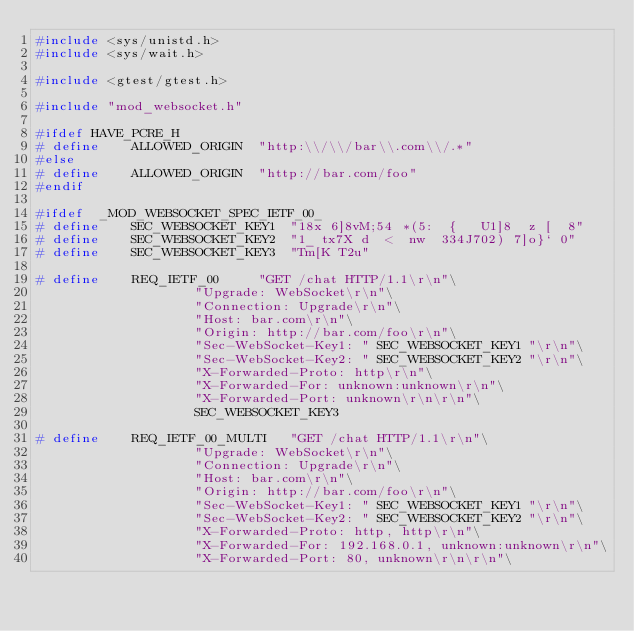Convert code to text. <code><loc_0><loc_0><loc_500><loc_500><_C++_>#include <sys/unistd.h>
#include <sys/wait.h>

#include <gtest/gtest.h>

#include "mod_websocket.h"

#ifdef HAVE_PCRE_H
# define	ALLOWED_ORIGIN	"http:\\/\\/bar\\.com\\/.*"
#else
# define	ALLOWED_ORIGIN	"http://bar.com/foo"
#endif

#ifdef	_MOD_WEBSOCKET_SPEC_IETF_00_
# define	SEC_WEBSOCKET_KEY1	"18x 6]8vM;54 *(5:  {   U1]8  z [  8"
# define	SEC_WEBSOCKET_KEY2	"1_ tx7X d  <  nw  334J702) 7]o}` 0"
# define	SEC_WEBSOCKET_KEY3	"Tm[K T2u"

# define	REQ_IETF_00		"GET /chat HTTP/1.1\r\n"\
					"Upgrade: WebSocket\r\n"\
					"Connection: Upgrade\r\n"\
					"Host: bar.com\r\n"\
					"Origin: http://bar.com/foo\r\n"\
					"Sec-WebSocket-Key1: " SEC_WEBSOCKET_KEY1 "\r\n"\
					"Sec-WebSocket-Key2: " SEC_WEBSOCKET_KEY2 "\r\n"\
					"X-Forwarded-Proto: http\r\n"\
					"X-Forwarded-For: unknown:unknown\r\n"\
					"X-Forwarded-Port: unknown\r\n\r\n"\
					SEC_WEBSOCKET_KEY3

# define	REQ_IETF_00_MULTI	"GET /chat HTTP/1.1\r\n"\
					"Upgrade: WebSocket\r\n"\
					"Connection: Upgrade\r\n"\
					"Host: bar.com\r\n"\
					"Origin: http://bar.com/foo\r\n"\
					"Sec-WebSocket-Key1: " SEC_WEBSOCKET_KEY1 "\r\n"\
					"Sec-WebSocket-Key2: " SEC_WEBSOCKET_KEY2 "\r\n"\
					"X-Forwarded-Proto: http, http\r\n"\
					"X-Forwarded-For: 192.168.0.1, unknown:unknown\r\n"\
					"X-Forwarded-Port: 80, unknown\r\n\r\n"\</code> 